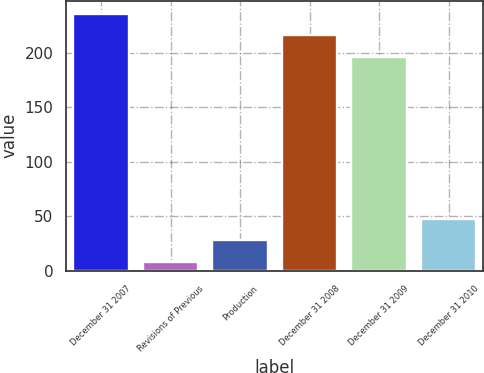Convert chart to OTSL. <chart><loc_0><loc_0><loc_500><loc_500><bar_chart><fcel>December 31 2007<fcel>Revisions of Previous<fcel>Production<fcel>December 31 2008<fcel>December 31 2009<fcel>December 31 2010<nl><fcel>235.8<fcel>8<fcel>27.9<fcel>215.9<fcel>196<fcel>47.8<nl></chart> 